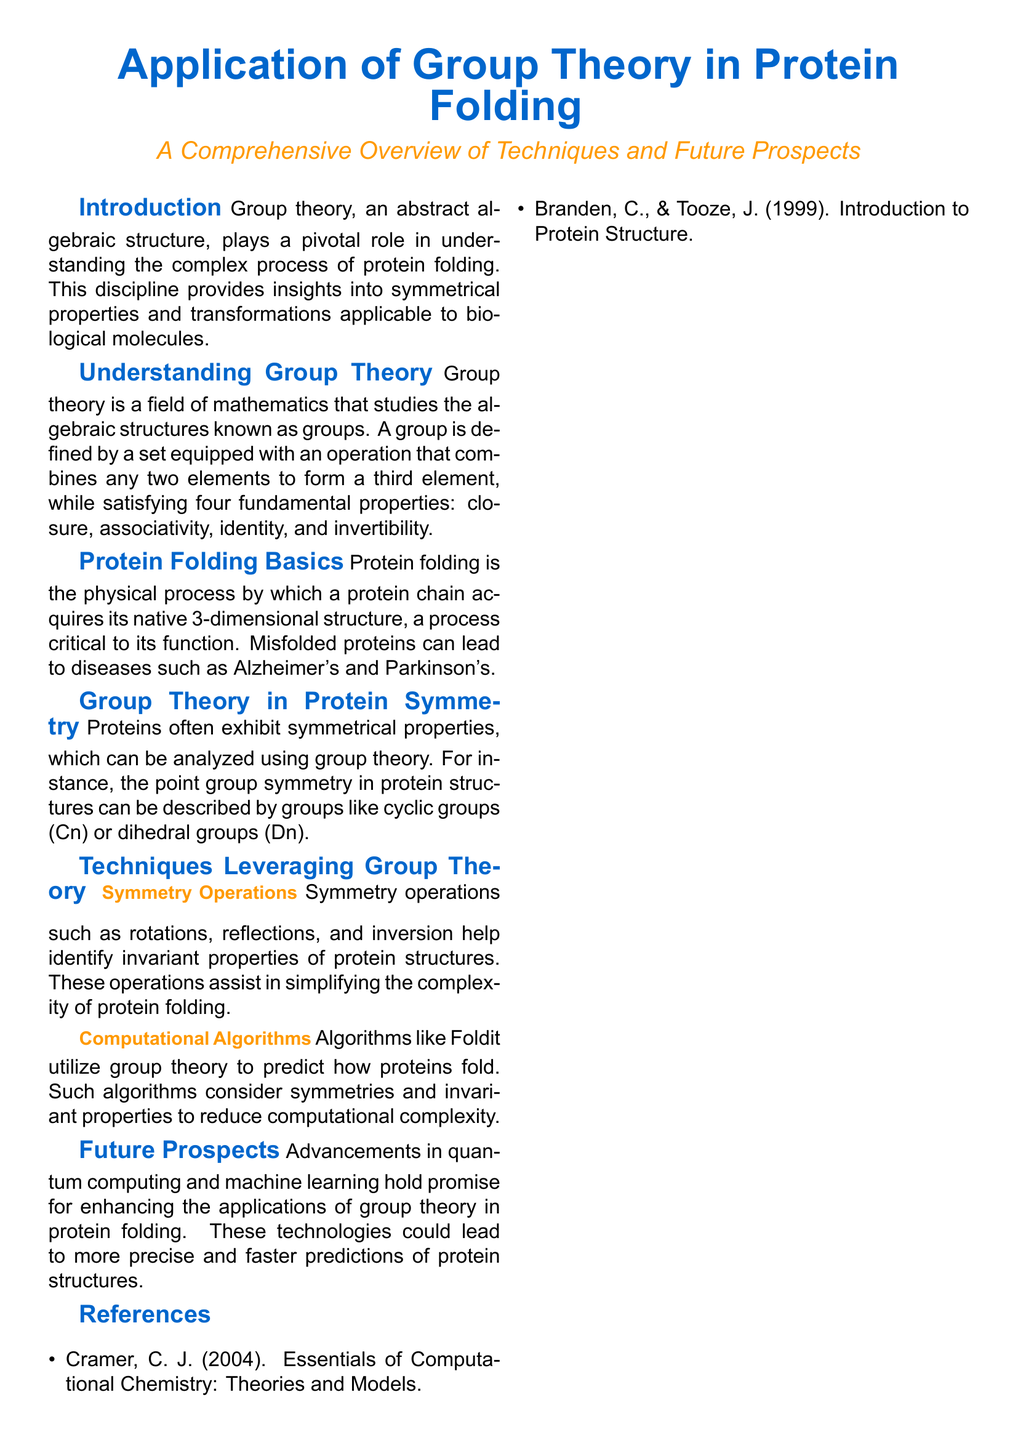What is the main topic of the flyer? The main topic is stated in the title of the document regarding the application of group theory in protein folding.
Answer: Application of Group Theory in Protein Folding What do symmetrical properties in proteins help analyze? Symmetrical properties in proteins can be analyzed using group theory to understand their features.
Answer: Symmetry What are two specific groups mentioned in the context of protein structures? Examples of groups used to describe protein structures are explicitly provided in the document.
Answer: Cyclic groups, dihedral groups What diseases are associated with misfolded proteins? The document mentions specific diseases caused by the misfolding of proteins, which are associated with cognitive decline.
Answer: Alzheimer’s and Parkinson’s What kind of advancements are expected to enhance group theory applications? The document highlights upcoming technological advancements likely to impact group theory and protein folding.
Answer: Quantum computing and machine learning How many figures are depicted in the visual guide? The visual section of the document states the number of figures that illustrate protein folding stages and mappings.
Answer: Two Which computational algorithms are mentioned? The document directly acknowledges a specific algorithm that utilizes group theory for predicting protein folding.
Answer: Foldit Who are the authors of the cited reference on protein structure? The reference section lists authors associated with a key textbook on protein structure.
Answer: Branden and Tooze 